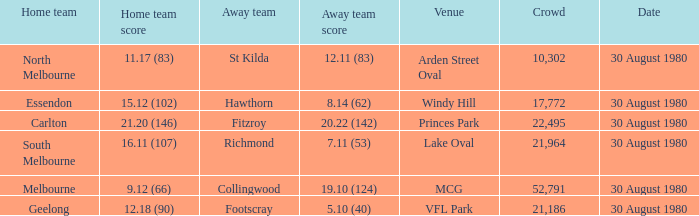What is the home team score at lake oval? 16.11 (107). 